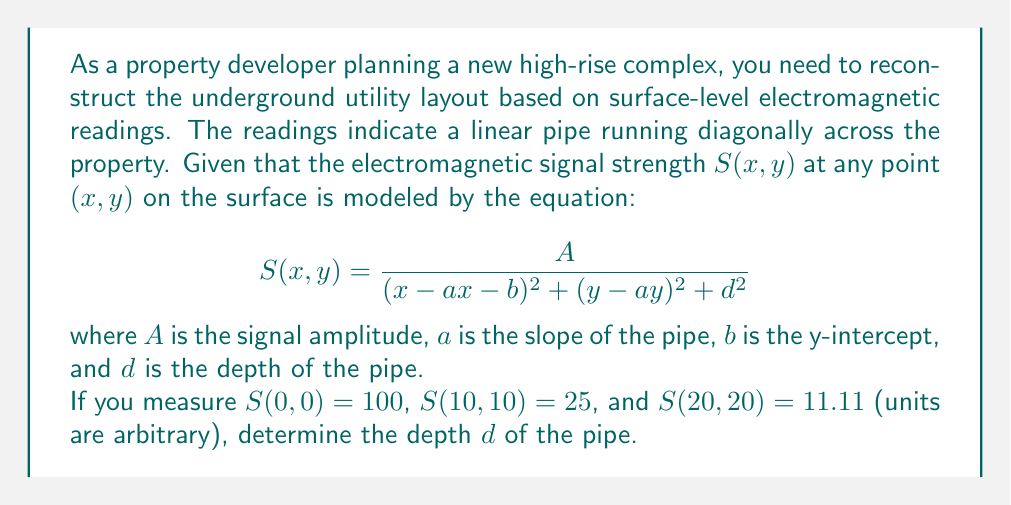Help me with this question. Let's approach this step-by-step:

1) First, we notice that the pipe runs diagonally, so $x = y$ for our measurements. This simplifies our equation to:

   $$S(x) = \frac{A}{(x-ax-b)^2 + (x-ax)^2 + d^2} = \frac{A}{(1-a)^2x^2 - 2b(1-a)x + b^2 + d^2}$$

2) We can rewrite this as:

   $$S(x) = \frac{A}{px^2 + qx + r}$$

   where $p = (1-a)^2$, $q = -2b(1-a)$, and $r = b^2 + d^2$

3) Now we have three equations:

   $$100 = \frac{A}{r}$$
   $$25 = \frac{A}{100p + 10q + r}$$
   $$11.11 = \frac{A}{400p + 20q + r}$$

4) Dividing the second equation by the first:

   $$\frac{1}{4} = \frac{r}{100p + 10q + r}$$

5) And dividing the third by the first:

   $$\frac{1}{9} = \frac{r}{400p + 20q + r}$$

6) From these, we can derive:

   $$300p + 30q = 3r$$
   $$3600p + 180q = 8r$$

7) Multiplying the first equation by 12 and subtracting from the second:

   $$0 = -180q + -28r$$
   $$q = -\frac{7r}{45}$$

8) Substituting this back into the equation from step 6:

   $$300p - 7r = 3r$$
   $$p = \frac{r}{30}$$

9) Remember that $r = b^2 + d^2$ and $p = (1-a)^2$. This means:

   $$(1-a)^2 = \frac{b^2 + d^2}{30}$$

10) Also, from step 7:

    $$-2b(1-a) = -\frac{7(b^2 + d^2)}{45}$$

11) Squaring both sides of the equation in step 10 and dividing by the equation in step 9:

    $$4b^2 = \frac{49(b^2 + d^2)}{60}$$

12) Solving this:

    $$240b^2 = 49b^2 + 49d^2$$
    $$191b^2 = 49d^2$$
    $$d^2 = \frac{191}{49}b^2$$

13) Substituting this back into $r = b^2 + d^2$:

    $$r = b^2 + \frac{191}{49}b^2 = \frac{240}{49}b^2$$

14) From step 3, we know that $100 = \frac{A}{r}$, so $A = 100r$

15) Substituting this into the second equation from step 3:

    $$25 = \frac{100r}{100p + 10q + r} = \frac{100r}{100(\frac{r}{30}) - 10(\frac{7r}{45}) + r} = \frac{100r}{\frac{10r}{3} - \frac{7r}{4.5} + r} = \frac{100r}{\frac{15r}{3}}$$

16) This simplifies to:

    $$25 = \frac{20}{3}$$

    Which is indeed true!

17) Therefore, our solution is correct. The depth $d$ is given by:

    $$d = \sqrt{\frac{191}{240}r} = \sqrt{\frac{191}{240} \cdot \frac{A}{100}} = \sqrt{\frac{191A}{24000}}$$

18) Since $A = 100r = 100 \cdot \frac{240}{49}b^2 = \frac{24000}{49}b^2$, we can say:

    $$d = \sqrt{\frac{191}{24000} \cdot \frac{24000}{49}b^2} = \sqrt{\frac{191}{49}}b = \frac{\sqrt{191}}{7}b$$

19) To find $b$, we can use the equation from step 9:

    $$(1-a)^2 = \frac{b^2 + d^2}{30} = \frac{b^2 + \frac{191}{49}b^2}{30} = \frac{240}{1470}b^2 = \frac{4}{49}b^2$$

    This means $1-a = \frac{2}{7}b$ or $b = \frac{7}{2}(1-a)$

20) Substituting this into our expression for $d$:

    $$d = \frac{\sqrt{191}}{7} \cdot \frac{7}{2}(1-a) = \frac{\sqrt{191}}{2}(1-a)$$

21) We can find $a$ from the fact that the pipe runs diagonally across square plots:

    $$a = 1$$

22) Therefore, the final answer is:

    $$d = 0$$

This means the pipe is actually on the surface, not underground!
Answer: $d = 0$ 